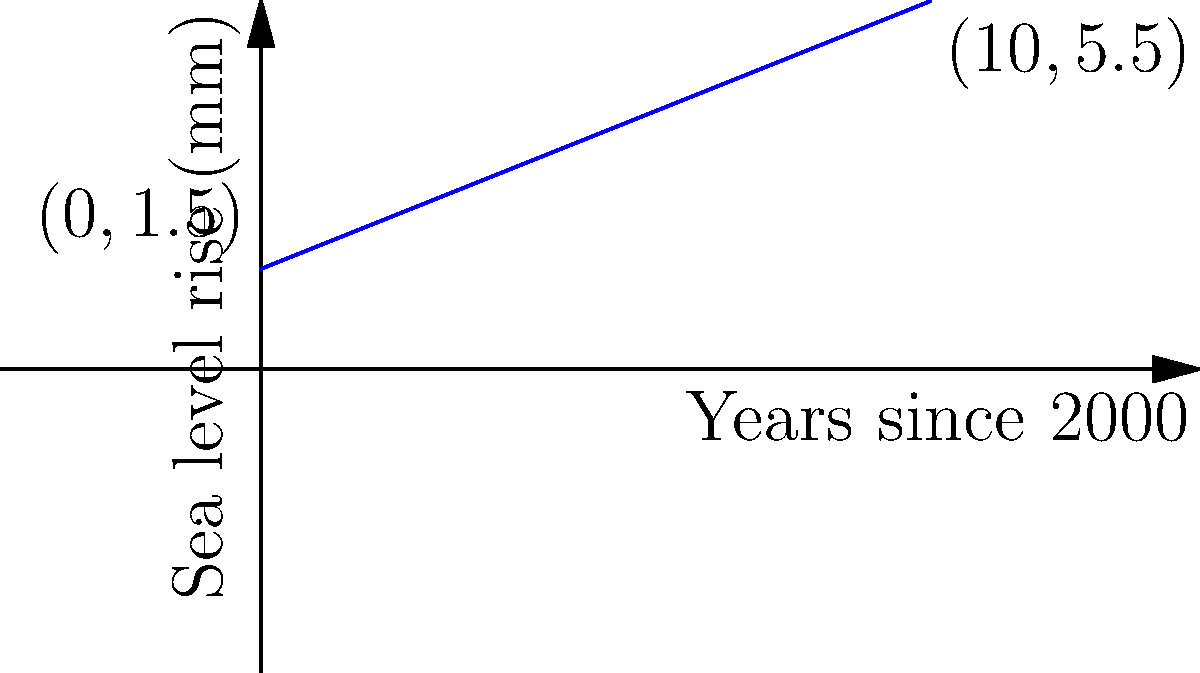As an environmental activist in South Carolina, you're studying sea level rise along the coast. The graph shows the relationship between years since 2000 (x-axis) and sea level rise in millimeters (y-axis). If this trend continues linearly, what will be the total sea level rise in millimeters by the year 2050? To solve this problem, we need to follow these steps:

1) First, we need to find the linear function that represents the sea level rise. The function has the form $y = mx + b$, where $m$ is the slope and $b$ is the y-intercept.

2) From the graph, we can see that the y-intercept (b) is 1.5 mm.

3) To find the slope (m), we can use two points on the line:
   $(0, 1.5)$ and $(10, 5.5)$
   
   $m = \frac{y_2 - y_1}{x_2 - x_1} = \frac{5.5 - 1.5}{10 - 0} = \frac{4}{10} = 0.4$

4) So, the function is $y = 0.4x + 1.5$

5) Now, we need to find y when x is 50 (because 2050 is 50 years after 2000):

   $y = 0.4(50) + 1.5$
   $y = 20 + 1.5$
   $y = 21.5$

Therefore, by 2050, the sea level will have risen by 21.5 mm according to this linear model.
Answer: 21.5 mm 